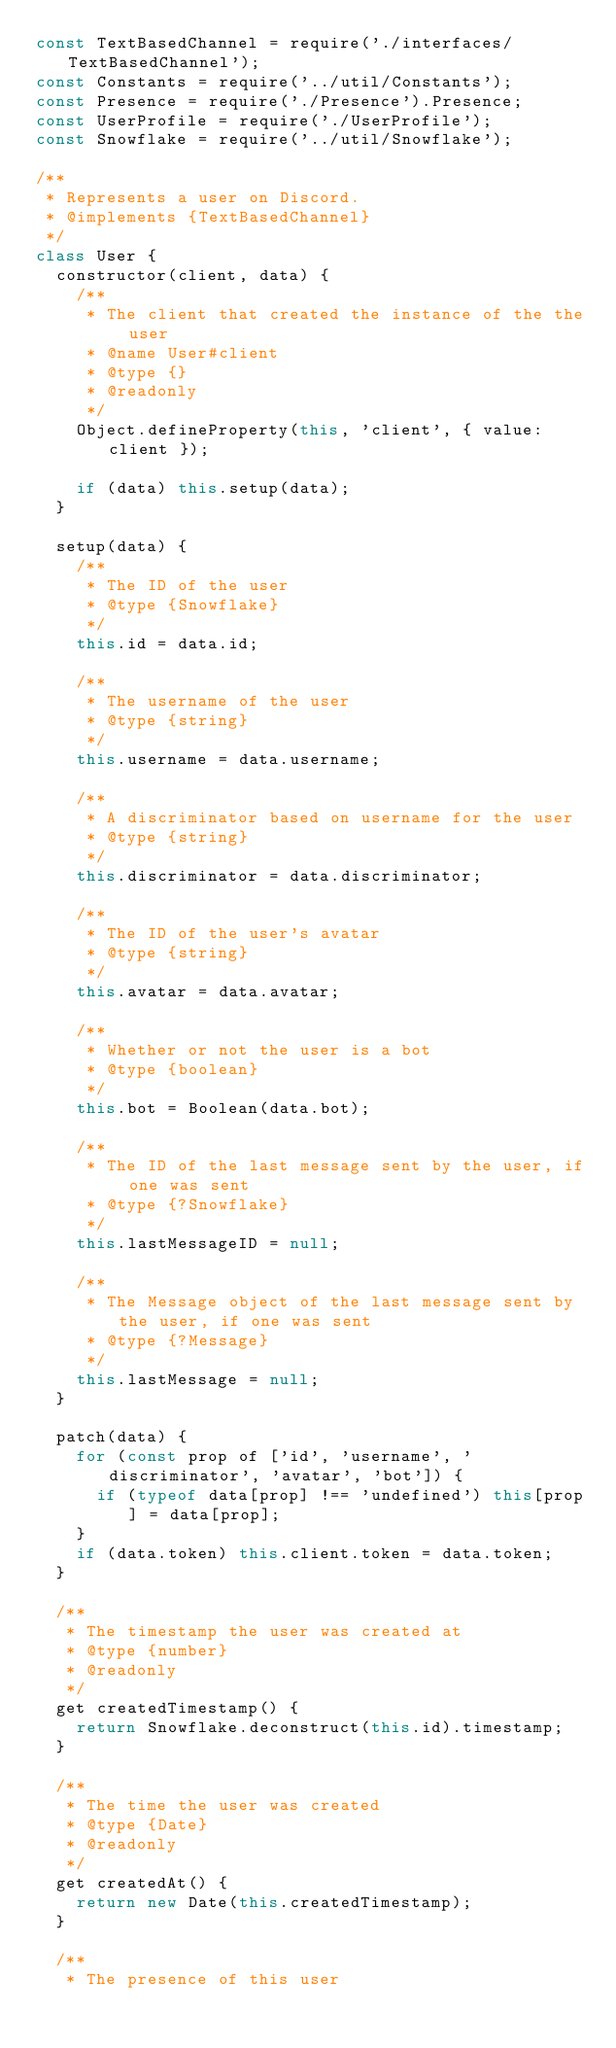Convert code to text. <code><loc_0><loc_0><loc_500><loc_500><_JavaScript_>const TextBasedChannel = require('./interfaces/TextBasedChannel');
const Constants = require('../util/Constants');
const Presence = require('./Presence').Presence;
const UserProfile = require('./UserProfile');
const Snowflake = require('../util/Snowflake');

/**
 * Represents a user on Discord.
 * @implements {TextBasedChannel}
 */
class User {
  constructor(client, data) {
    /**
     * The client that created the instance of the the user
     * @name User#client
     * @type {}
     * @readonly
     */
    Object.defineProperty(this, 'client', { value: client });

    if (data) this.setup(data);
  }

  setup(data) {
    /**
     * The ID of the user
     * @type {Snowflake}
     */
    this.id = data.id;

    /**
     * The username of the user
     * @type {string}
     */
    this.username = data.username;

    /**
     * A discriminator based on username for the user
     * @type {string}
     */
    this.discriminator = data.discriminator;

    /**
     * The ID of the user's avatar
     * @type {string}
     */
    this.avatar = data.avatar;

    /**
     * Whether or not the user is a bot
     * @type {boolean}
     */
    this.bot = Boolean(data.bot);

    /**
     * The ID of the last message sent by the user, if one was sent
     * @type {?Snowflake}
     */
    this.lastMessageID = null;

    /**
     * The Message object of the last message sent by the user, if one was sent
     * @type {?Message}
     */
    this.lastMessage = null;
  }

  patch(data) {
    for (const prop of ['id', 'username', 'discriminator', 'avatar', 'bot']) {
      if (typeof data[prop] !== 'undefined') this[prop] = data[prop];
    }
    if (data.token) this.client.token = data.token;
  }

  /**
   * The timestamp the user was created at
   * @type {number}
   * @readonly
   */
  get createdTimestamp() {
    return Snowflake.deconstruct(this.id).timestamp;
  }

  /**
   * The time the user was created
   * @type {Date}
   * @readonly
   */
  get createdAt() {
    return new Date(this.createdTimestamp);
  }

  /**
   * The presence of this user</code> 